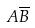Convert formula to latex. <formula><loc_0><loc_0><loc_500><loc_500>A \overline { B }</formula> 